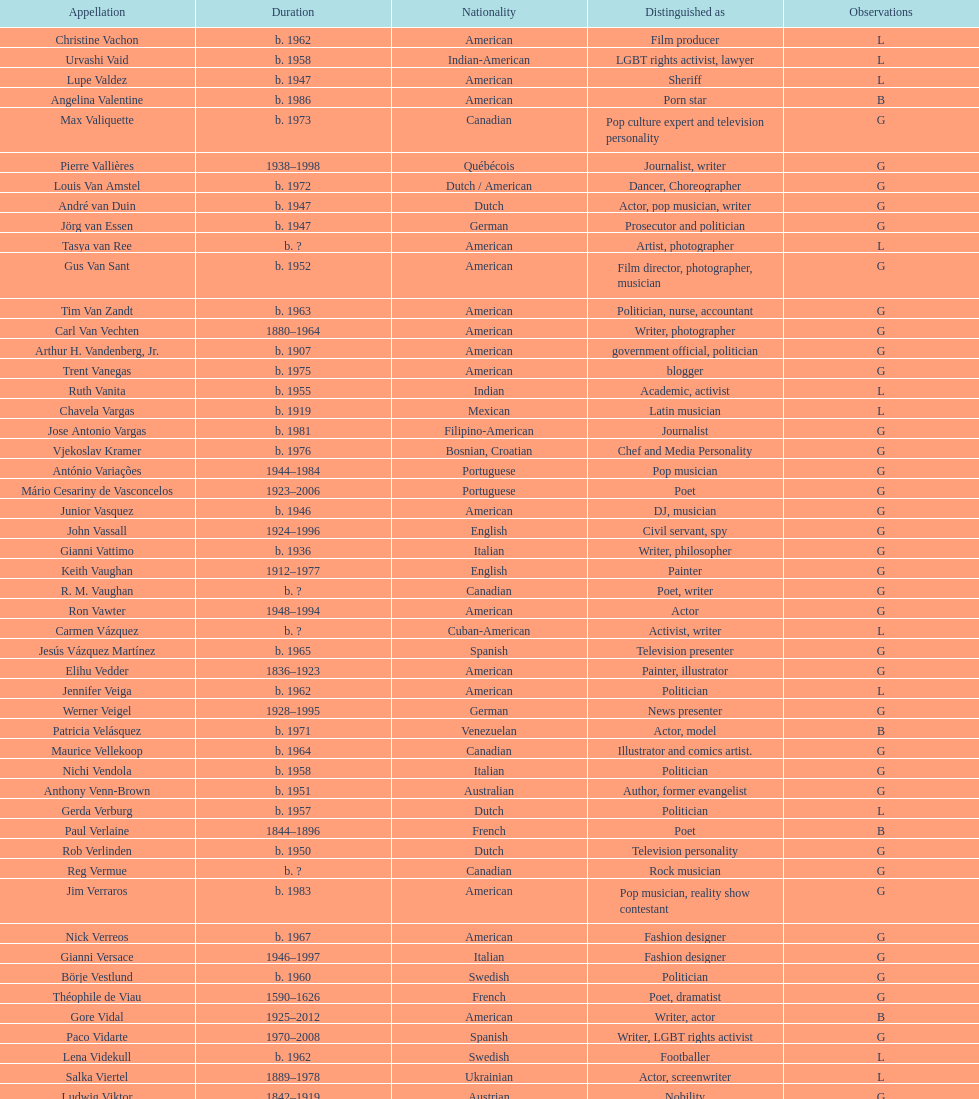What is the difference in year of borth between vachon and vaid? 4 years. 